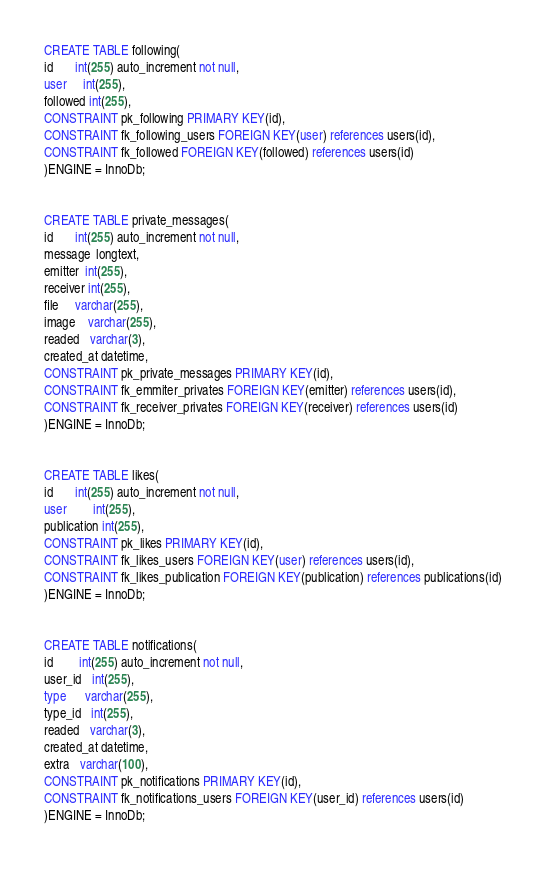Convert code to text. <code><loc_0><loc_0><loc_500><loc_500><_SQL_>CREATE TABLE following(
id       int(255) auto_increment not null,
user     int(255),
followed int(255),
CONSTRAINT pk_following PRIMARY KEY(id),
CONSTRAINT fk_following_users FOREIGN KEY(user) references users(id),
CONSTRAINT fk_followed FOREIGN KEY(followed) references users(id)
)ENGINE = InnoDb;


CREATE TABLE private_messages(
id       int(255) auto_increment not null,
message  longtext,
emitter  int(255),
receiver int(255),
file     varchar(255),
image    varchar(255),
readed   varchar(3),
created_at datetime,
CONSTRAINT pk_private_messages PRIMARY KEY(id),
CONSTRAINT fk_emmiter_privates FOREIGN KEY(emitter) references users(id),
CONSTRAINT fk_receiver_privates FOREIGN KEY(receiver) references users(id)
)ENGINE = InnoDb;


CREATE TABLE likes(
id       int(255) auto_increment not null,
user        int(255),
publication int(255),
CONSTRAINT pk_likes PRIMARY KEY(id),
CONSTRAINT fk_likes_users FOREIGN KEY(user) references users(id),
CONSTRAINT fk_likes_publication FOREIGN KEY(publication) references publications(id)
)ENGINE = InnoDb;


CREATE TABLE notifications(
id        int(255) auto_increment not null,
user_id   int(255),
type      varchar(255),
type_id   int(255),
readed   varchar(3),
created_at datetime,
extra   varchar(100),
CONSTRAINT pk_notifications PRIMARY KEY(id),
CONSTRAINT fk_notifications_users FOREIGN KEY(user_id) references users(id)
)ENGINE = InnoDb;</code> 